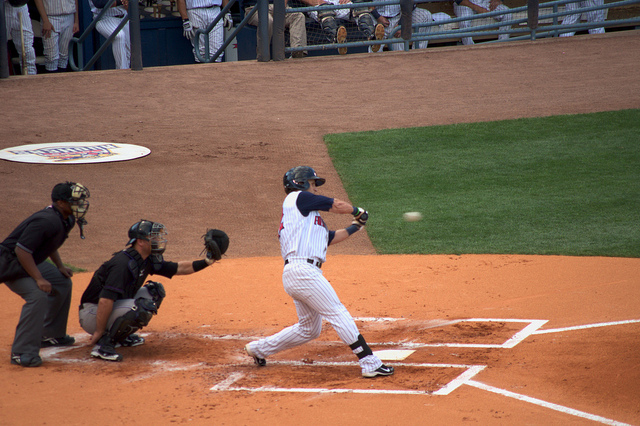How many people are there? In the image, there are two people visible - one is batting while the other is catching behind the home plate in a baseball game. 